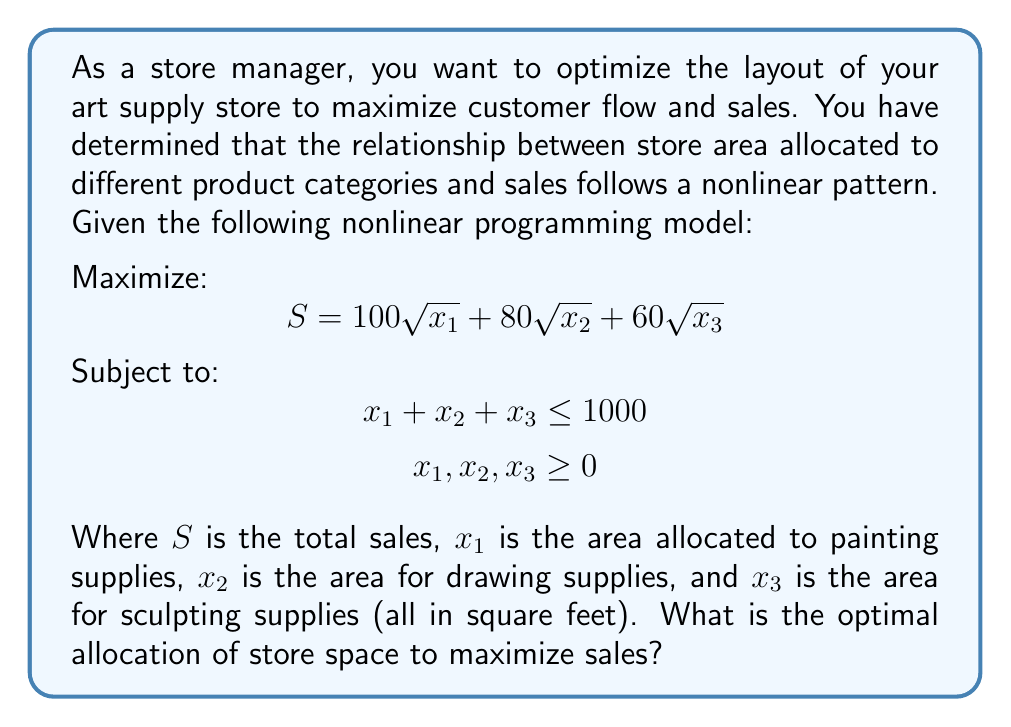Help me with this question. To solve this nonlinear programming problem, we can use the method of Lagrange multipliers:

1. Form the Lagrangian function:
   $$ L(x_1, x_2, x_3, \lambda) = 100\sqrt{x_1} + 80\sqrt{x_2} + 60\sqrt{x_3} - \lambda(x_1 + x_2 + x_3 - 1000) $$

2. Take partial derivatives and set them equal to zero:
   $$ \frac{\partial L}{\partial x_1} = \frac{50}{\sqrt{x_1}} - \lambda = 0 $$
   $$ \frac{\partial L}{\partial x_2} = \frac{40}{\sqrt{x_2}} - \lambda = 0 $$
   $$ \frac{\partial L}{\partial x_3} = \frac{30}{\sqrt{x_3}} - \lambda = 0 $$
   $$ \frac{\partial L}{\partial \lambda} = -(x_1 + x_2 + x_3 - 1000) = 0 $$

3. From the first three equations:
   $$ \frac{50}{\sqrt{x_1}} = \frac{40}{\sqrt{x_2}} = \frac{30}{\sqrt{x_3}} = \lambda $$

4. This implies:
   $$ \frac{x_1}{25^2} = \frac{x_2}{20^2} = \frac{x_3}{15^2} $$

5. Let $k = \frac{x_1}{25^2} = \frac{x_2}{20^2} = \frac{x_3}{15^2}$. Then:
   $$ x_1 = 625k, \quad x_2 = 400k, \quad x_3 = 225k $$

6. Substitute into the constraint equation:
   $$ 625k + 400k + 225k = 1000 $$
   $$ 1250k = 1000 $$
   $$ k = \frac{4}{5} $$

7. Solve for $x_1, x_2, x_3$:
   $$ x_1 = 625 \cdot \frac{4}{5} = 500 $$
   $$ x_2 = 400 \cdot \frac{4}{5} = 320 $$
   $$ x_3 = 225 \cdot \frac{4}{5} = 180 $$

Therefore, the optimal allocation of store space is 500 sq ft for painting supplies, 320 sq ft for drawing supplies, and 180 sq ft for sculpting supplies.
Answer: $(500, 320, 180)$ 